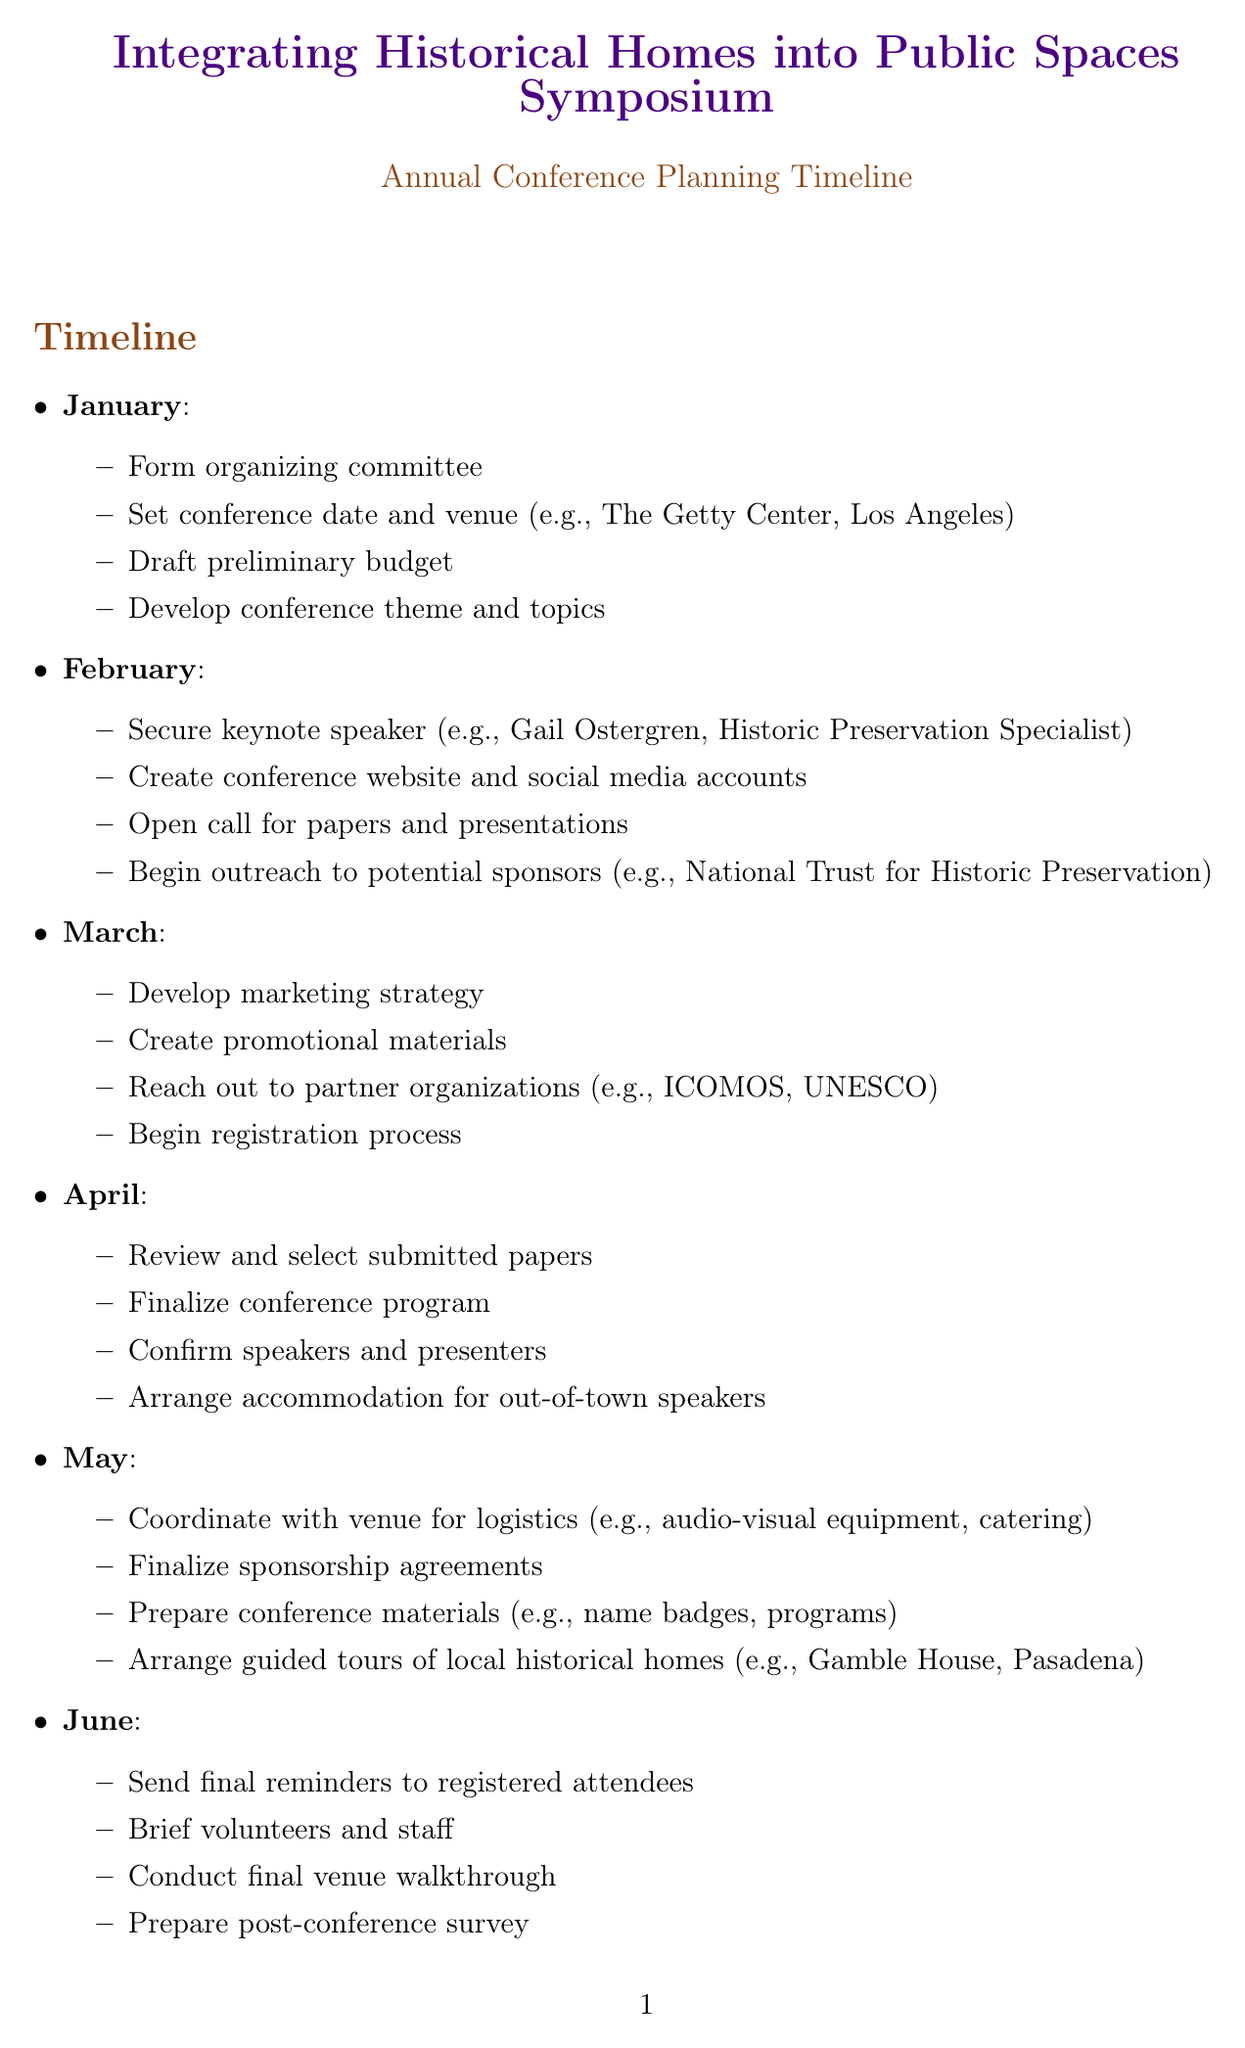What is the conference title? The conference title is explicitly stated at the beginning of the document.
Answer: Integrating Historical Homes into Public Spaces Symposium Which month is the keynote speaker secured? The document provides a monthly breakdown of tasks, including when to secure the keynote speaker.
Answer: February How many workshop ideas are listed? The number of workshop ideas can be counted based on the list provided in the document.
Answer: Five What is one of the key topics of the symposium? The document lists key topics, and any item from that list would answer this question.
Answer: Adaptive reuse of historical homes Who is the potential speaker associated with sustainability in historic preservation? The document mentions specific speakers and their associated topics, making it straightforward to identify the right one.
Answer: Dr. Erica Avrami What task is scheduled for June? The document details tasks for each month, allowing for direct retrieval of the June activities listed.
Answer: Send final reminders to registered attendees In which month does the conference take place? By analyzing the timeline in the document, one can determine when the conference is hosted.
Answer: July What task involves logistics coordination? The specific task about coordinating logistics can be found in the outline provided for May.
Answer: Coordinate with venue for logistics 